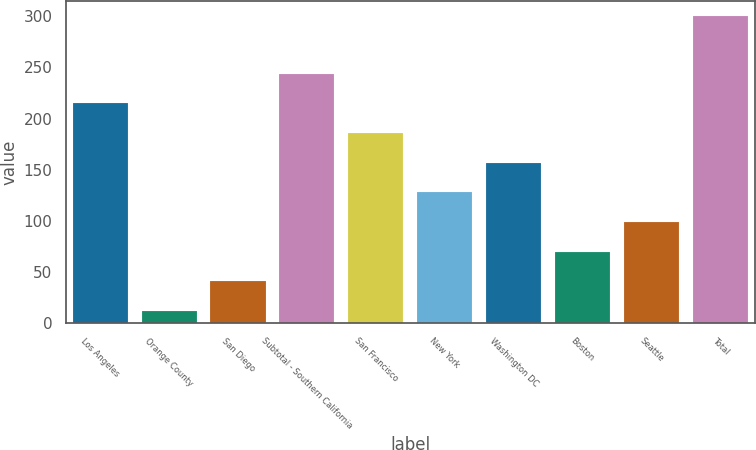Convert chart. <chart><loc_0><loc_0><loc_500><loc_500><bar_chart><fcel>Los Angeles<fcel>Orange County<fcel>San Diego<fcel>Subtotal - Southern California<fcel>San Francisco<fcel>New York<fcel>Washington DC<fcel>Boston<fcel>Seattle<fcel>Total<nl><fcel>215<fcel>12<fcel>41<fcel>244<fcel>186<fcel>128<fcel>157<fcel>70<fcel>99<fcel>300<nl></chart> 